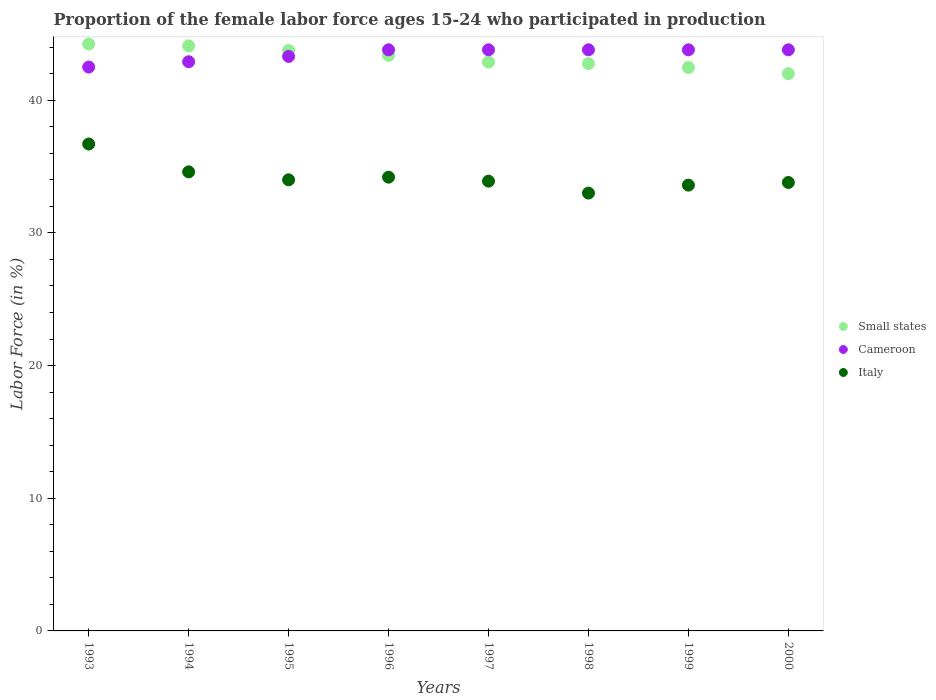How many different coloured dotlines are there?
Your answer should be compact. 3. Is the number of dotlines equal to the number of legend labels?
Offer a terse response. Yes. What is the proportion of the female labor force who participated in production in Cameroon in 1999?
Provide a short and direct response. 43.8. Across all years, what is the maximum proportion of the female labor force who participated in production in Small states?
Your response must be concise. 44.24. Across all years, what is the minimum proportion of the female labor force who participated in production in Small states?
Ensure brevity in your answer.  42. In which year was the proportion of the female labor force who participated in production in Cameroon maximum?
Provide a succinct answer. 1996. What is the total proportion of the female labor force who participated in production in Cameroon in the graph?
Make the answer very short. 347.7. What is the difference between the proportion of the female labor force who participated in production in Cameroon in 1994 and that in 2000?
Provide a succinct answer. -0.9. What is the difference between the proportion of the female labor force who participated in production in Italy in 1998 and the proportion of the female labor force who participated in production in Cameroon in 1997?
Provide a short and direct response. -10.8. What is the average proportion of the female labor force who participated in production in Small states per year?
Your answer should be very brief. 43.19. In the year 1998, what is the difference between the proportion of the female labor force who participated in production in Cameroon and proportion of the female labor force who participated in production in Small states?
Your answer should be compact. 1.04. In how many years, is the proportion of the female labor force who participated in production in Small states greater than 18 %?
Keep it short and to the point. 8. What is the ratio of the proportion of the female labor force who participated in production in Small states in 1994 to that in 1998?
Provide a succinct answer. 1.03. What is the difference between the highest and the lowest proportion of the female labor force who participated in production in Italy?
Provide a succinct answer. 3.7. In how many years, is the proportion of the female labor force who participated in production in Small states greater than the average proportion of the female labor force who participated in production in Small states taken over all years?
Offer a very short reply. 4. Does the proportion of the female labor force who participated in production in Cameroon monotonically increase over the years?
Offer a very short reply. No. How many dotlines are there?
Your answer should be very brief. 3. How many years are there in the graph?
Your response must be concise. 8. What is the difference between two consecutive major ticks on the Y-axis?
Make the answer very short. 10. Are the values on the major ticks of Y-axis written in scientific E-notation?
Provide a short and direct response. No. Does the graph contain any zero values?
Offer a very short reply. No. Does the graph contain grids?
Ensure brevity in your answer.  No. Where does the legend appear in the graph?
Your answer should be very brief. Center right. What is the title of the graph?
Provide a short and direct response. Proportion of the female labor force ages 15-24 who participated in production. What is the label or title of the Y-axis?
Your answer should be compact. Labor Force (in %). What is the Labor Force (in %) in Small states in 1993?
Offer a very short reply. 44.24. What is the Labor Force (in %) of Cameroon in 1993?
Give a very brief answer. 42.5. What is the Labor Force (in %) of Italy in 1993?
Give a very brief answer. 36.7. What is the Labor Force (in %) in Small states in 1994?
Provide a short and direct response. 44.1. What is the Labor Force (in %) of Cameroon in 1994?
Provide a succinct answer. 42.9. What is the Labor Force (in %) of Italy in 1994?
Give a very brief answer. 34.6. What is the Labor Force (in %) of Small states in 1995?
Make the answer very short. 43.75. What is the Labor Force (in %) in Cameroon in 1995?
Provide a succinct answer. 43.3. What is the Labor Force (in %) in Italy in 1995?
Offer a very short reply. 34. What is the Labor Force (in %) of Small states in 1996?
Give a very brief answer. 43.38. What is the Labor Force (in %) in Cameroon in 1996?
Provide a succinct answer. 43.8. What is the Labor Force (in %) of Italy in 1996?
Give a very brief answer. 34.2. What is the Labor Force (in %) in Small states in 1997?
Your answer should be very brief. 42.88. What is the Labor Force (in %) in Cameroon in 1997?
Your response must be concise. 43.8. What is the Labor Force (in %) in Italy in 1997?
Ensure brevity in your answer.  33.9. What is the Labor Force (in %) in Small states in 1998?
Your answer should be very brief. 42.76. What is the Labor Force (in %) of Cameroon in 1998?
Provide a succinct answer. 43.8. What is the Labor Force (in %) in Small states in 1999?
Your response must be concise. 42.46. What is the Labor Force (in %) of Cameroon in 1999?
Provide a short and direct response. 43.8. What is the Labor Force (in %) of Italy in 1999?
Give a very brief answer. 33.6. What is the Labor Force (in %) in Small states in 2000?
Keep it short and to the point. 42. What is the Labor Force (in %) of Cameroon in 2000?
Keep it short and to the point. 43.8. What is the Labor Force (in %) in Italy in 2000?
Make the answer very short. 33.8. Across all years, what is the maximum Labor Force (in %) in Small states?
Your response must be concise. 44.24. Across all years, what is the maximum Labor Force (in %) of Cameroon?
Keep it short and to the point. 43.8. Across all years, what is the maximum Labor Force (in %) of Italy?
Your answer should be compact. 36.7. Across all years, what is the minimum Labor Force (in %) of Small states?
Offer a terse response. 42. Across all years, what is the minimum Labor Force (in %) of Cameroon?
Give a very brief answer. 42.5. Across all years, what is the minimum Labor Force (in %) in Italy?
Your response must be concise. 33. What is the total Labor Force (in %) of Small states in the graph?
Give a very brief answer. 345.56. What is the total Labor Force (in %) of Cameroon in the graph?
Ensure brevity in your answer.  347.7. What is the total Labor Force (in %) in Italy in the graph?
Make the answer very short. 273.8. What is the difference between the Labor Force (in %) of Small states in 1993 and that in 1994?
Provide a succinct answer. 0.14. What is the difference between the Labor Force (in %) in Cameroon in 1993 and that in 1994?
Your response must be concise. -0.4. What is the difference between the Labor Force (in %) in Italy in 1993 and that in 1994?
Your answer should be very brief. 2.1. What is the difference between the Labor Force (in %) in Small states in 1993 and that in 1995?
Make the answer very short. 0.49. What is the difference between the Labor Force (in %) in Cameroon in 1993 and that in 1995?
Provide a short and direct response. -0.8. What is the difference between the Labor Force (in %) of Small states in 1993 and that in 1996?
Keep it short and to the point. 0.85. What is the difference between the Labor Force (in %) of Cameroon in 1993 and that in 1996?
Your answer should be very brief. -1.3. What is the difference between the Labor Force (in %) of Italy in 1993 and that in 1996?
Ensure brevity in your answer.  2.5. What is the difference between the Labor Force (in %) of Small states in 1993 and that in 1997?
Provide a short and direct response. 1.36. What is the difference between the Labor Force (in %) in Cameroon in 1993 and that in 1997?
Your response must be concise. -1.3. What is the difference between the Labor Force (in %) in Small states in 1993 and that in 1998?
Your response must be concise. 1.48. What is the difference between the Labor Force (in %) in Small states in 1993 and that in 1999?
Offer a very short reply. 1.77. What is the difference between the Labor Force (in %) of Cameroon in 1993 and that in 1999?
Your answer should be very brief. -1.3. What is the difference between the Labor Force (in %) of Italy in 1993 and that in 1999?
Offer a terse response. 3.1. What is the difference between the Labor Force (in %) of Small states in 1993 and that in 2000?
Your answer should be compact. 2.23. What is the difference between the Labor Force (in %) in Cameroon in 1993 and that in 2000?
Your answer should be compact. -1.3. What is the difference between the Labor Force (in %) in Italy in 1993 and that in 2000?
Keep it short and to the point. 2.9. What is the difference between the Labor Force (in %) in Small states in 1994 and that in 1995?
Your response must be concise. 0.35. What is the difference between the Labor Force (in %) in Italy in 1994 and that in 1995?
Ensure brevity in your answer.  0.6. What is the difference between the Labor Force (in %) of Small states in 1994 and that in 1996?
Offer a terse response. 0.72. What is the difference between the Labor Force (in %) in Small states in 1994 and that in 1997?
Your answer should be very brief. 1.22. What is the difference between the Labor Force (in %) in Cameroon in 1994 and that in 1997?
Ensure brevity in your answer.  -0.9. What is the difference between the Labor Force (in %) of Italy in 1994 and that in 1997?
Offer a terse response. 0.7. What is the difference between the Labor Force (in %) in Small states in 1994 and that in 1998?
Ensure brevity in your answer.  1.34. What is the difference between the Labor Force (in %) of Cameroon in 1994 and that in 1998?
Provide a short and direct response. -0.9. What is the difference between the Labor Force (in %) of Small states in 1994 and that in 1999?
Provide a succinct answer. 1.63. What is the difference between the Labor Force (in %) of Italy in 1994 and that in 1999?
Give a very brief answer. 1. What is the difference between the Labor Force (in %) in Small states in 1994 and that in 2000?
Keep it short and to the point. 2.09. What is the difference between the Labor Force (in %) of Cameroon in 1994 and that in 2000?
Provide a succinct answer. -0.9. What is the difference between the Labor Force (in %) in Italy in 1994 and that in 2000?
Your answer should be compact. 0.8. What is the difference between the Labor Force (in %) in Small states in 1995 and that in 1996?
Keep it short and to the point. 0.36. What is the difference between the Labor Force (in %) in Cameroon in 1995 and that in 1996?
Your answer should be compact. -0.5. What is the difference between the Labor Force (in %) in Small states in 1995 and that in 1997?
Provide a succinct answer. 0.87. What is the difference between the Labor Force (in %) of Cameroon in 1995 and that in 1997?
Ensure brevity in your answer.  -0.5. What is the difference between the Labor Force (in %) of Italy in 1995 and that in 1997?
Provide a short and direct response. 0.1. What is the difference between the Labor Force (in %) of Small states in 1995 and that in 1998?
Give a very brief answer. 0.99. What is the difference between the Labor Force (in %) of Small states in 1995 and that in 1999?
Your response must be concise. 1.28. What is the difference between the Labor Force (in %) in Italy in 1995 and that in 1999?
Offer a very short reply. 0.4. What is the difference between the Labor Force (in %) in Small states in 1995 and that in 2000?
Provide a succinct answer. 1.74. What is the difference between the Labor Force (in %) in Italy in 1995 and that in 2000?
Offer a terse response. 0.2. What is the difference between the Labor Force (in %) of Small states in 1996 and that in 1997?
Keep it short and to the point. 0.5. What is the difference between the Labor Force (in %) in Small states in 1996 and that in 1998?
Your response must be concise. 0.62. What is the difference between the Labor Force (in %) of Cameroon in 1996 and that in 1998?
Give a very brief answer. 0. What is the difference between the Labor Force (in %) in Italy in 1996 and that in 1998?
Keep it short and to the point. 1.2. What is the difference between the Labor Force (in %) in Small states in 1996 and that in 1999?
Make the answer very short. 0.92. What is the difference between the Labor Force (in %) in Small states in 1996 and that in 2000?
Give a very brief answer. 1.38. What is the difference between the Labor Force (in %) of Cameroon in 1996 and that in 2000?
Provide a short and direct response. 0. What is the difference between the Labor Force (in %) in Small states in 1997 and that in 1998?
Offer a very short reply. 0.12. What is the difference between the Labor Force (in %) of Cameroon in 1997 and that in 1998?
Offer a very short reply. 0. What is the difference between the Labor Force (in %) of Italy in 1997 and that in 1998?
Your response must be concise. 0.9. What is the difference between the Labor Force (in %) in Small states in 1997 and that in 1999?
Provide a succinct answer. 0.41. What is the difference between the Labor Force (in %) of Italy in 1997 and that in 1999?
Your answer should be very brief. 0.3. What is the difference between the Labor Force (in %) of Small states in 1997 and that in 2000?
Make the answer very short. 0.88. What is the difference between the Labor Force (in %) of Italy in 1997 and that in 2000?
Offer a terse response. 0.1. What is the difference between the Labor Force (in %) in Small states in 1998 and that in 1999?
Offer a terse response. 0.29. What is the difference between the Labor Force (in %) of Cameroon in 1998 and that in 1999?
Ensure brevity in your answer.  0. What is the difference between the Labor Force (in %) in Italy in 1998 and that in 1999?
Offer a very short reply. -0.6. What is the difference between the Labor Force (in %) in Small states in 1998 and that in 2000?
Your response must be concise. 0.75. What is the difference between the Labor Force (in %) in Cameroon in 1998 and that in 2000?
Make the answer very short. 0. What is the difference between the Labor Force (in %) of Small states in 1999 and that in 2000?
Offer a terse response. 0.46. What is the difference between the Labor Force (in %) in Cameroon in 1999 and that in 2000?
Your answer should be very brief. 0. What is the difference between the Labor Force (in %) in Italy in 1999 and that in 2000?
Keep it short and to the point. -0.2. What is the difference between the Labor Force (in %) of Small states in 1993 and the Labor Force (in %) of Cameroon in 1994?
Keep it short and to the point. 1.33. What is the difference between the Labor Force (in %) in Small states in 1993 and the Labor Force (in %) in Italy in 1994?
Your answer should be very brief. 9.63. What is the difference between the Labor Force (in %) in Small states in 1993 and the Labor Force (in %) in Cameroon in 1995?
Your response must be concise. 0.94. What is the difference between the Labor Force (in %) of Small states in 1993 and the Labor Force (in %) of Italy in 1995?
Your answer should be very brief. 10.23. What is the difference between the Labor Force (in %) in Small states in 1993 and the Labor Force (in %) in Cameroon in 1996?
Provide a short and direct response. 0.43. What is the difference between the Labor Force (in %) of Small states in 1993 and the Labor Force (in %) of Italy in 1996?
Your answer should be very brief. 10.04. What is the difference between the Labor Force (in %) in Cameroon in 1993 and the Labor Force (in %) in Italy in 1996?
Your answer should be compact. 8.3. What is the difference between the Labor Force (in %) in Small states in 1993 and the Labor Force (in %) in Cameroon in 1997?
Ensure brevity in your answer.  0.43. What is the difference between the Labor Force (in %) of Small states in 1993 and the Labor Force (in %) of Italy in 1997?
Provide a short and direct response. 10.34. What is the difference between the Labor Force (in %) in Cameroon in 1993 and the Labor Force (in %) in Italy in 1997?
Ensure brevity in your answer.  8.6. What is the difference between the Labor Force (in %) in Small states in 1993 and the Labor Force (in %) in Cameroon in 1998?
Keep it short and to the point. 0.43. What is the difference between the Labor Force (in %) in Small states in 1993 and the Labor Force (in %) in Italy in 1998?
Ensure brevity in your answer.  11.23. What is the difference between the Labor Force (in %) in Small states in 1993 and the Labor Force (in %) in Cameroon in 1999?
Keep it short and to the point. 0.43. What is the difference between the Labor Force (in %) of Small states in 1993 and the Labor Force (in %) of Italy in 1999?
Ensure brevity in your answer.  10.63. What is the difference between the Labor Force (in %) in Cameroon in 1993 and the Labor Force (in %) in Italy in 1999?
Offer a terse response. 8.9. What is the difference between the Labor Force (in %) of Small states in 1993 and the Labor Force (in %) of Cameroon in 2000?
Offer a very short reply. 0.43. What is the difference between the Labor Force (in %) of Small states in 1993 and the Labor Force (in %) of Italy in 2000?
Provide a succinct answer. 10.44. What is the difference between the Labor Force (in %) in Cameroon in 1993 and the Labor Force (in %) in Italy in 2000?
Ensure brevity in your answer.  8.7. What is the difference between the Labor Force (in %) in Small states in 1994 and the Labor Force (in %) in Cameroon in 1995?
Make the answer very short. 0.8. What is the difference between the Labor Force (in %) of Small states in 1994 and the Labor Force (in %) of Italy in 1995?
Keep it short and to the point. 10.1. What is the difference between the Labor Force (in %) in Cameroon in 1994 and the Labor Force (in %) in Italy in 1995?
Offer a terse response. 8.9. What is the difference between the Labor Force (in %) of Small states in 1994 and the Labor Force (in %) of Cameroon in 1996?
Your answer should be very brief. 0.3. What is the difference between the Labor Force (in %) in Small states in 1994 and the Labor Force (in %) in Italy in 1996?
Ensure brevity in your answer.  9.9. What is the difference between the Labor Force (in %) of Cameroon in 1994 and the Labor Force (in %) of Italy in 1996?
Offer a very short reply. 8.7. What is the difference between the Labor Force (in %) in Small states in 1994 and the Labor Force (in %) in Cameroon in 1997?
Offer a very short reply. 0.3. What is the difference between the Labor Force (in %) of Small states in 1994 and the Labor Force (in %) of Italy in 1997?
Provide a succinct answer. 10.2. What is the difference between the Labor Force (in %) in Cameroon in 1994 and the Labor Force (in %) in Italy in 1997?
Your response must be concise. 9. What is the difference between the Labor Force (in %) of Small states in 1994 and the Labor Force (in %) of Cameroon in 1998?
Offer a very short reply. 0.3. What is the difference between the Labor Force (in %) of Small states in 1994 and the Labor Force (in %) of Italy in 1998?
Offer a very short reply. 11.1. What is the difference between the Labor Force (in %) in Small states in 1994 and the Labor Force (in %) in Cameroon in 1999?
Offer a terse response. 0.3. What is the difference between the Labor Force (in %) of Small states in 1994 and the Labor Force (in %) of Italy in 1999?
Ensure brevity in your answer.  10.5. What is the difference between the Labor Force (in %) of Cameroon in 1994 and the Labor Force (in %) of Italy in 1999?
Your answer should be compact. 9.3. What is the difference between the Labor Force (in %) of Small states in 1994 and the Labor Force (in %) of Cameroon in 2000?
Your answer should be very brief. 0.3. What is the difference between the Labor Force (in %) of Small states in 1994 and the Labor Force (in %) of Italy in 2000?
Offer a terse response. 10.3. What is the difference between the Labor Force (in %) of Cameroon in 1994 and the Labor Force (in %) of Italy in 2000?
Make the answer very short. 9.1. What is the difference between the Labor Force (in %) of Small states in 1995 and the Labor Force (in %) of Cameroon in 1996?
Offer a terse response. -0.05. What is the difference between the Labor Force (in %) of Small states in 1995 and the Labor Force (in %) of Italy in 1996?
Offer a very short reply. 9.55. What is the difference between the Labor Force (in %) of Cameroon in 1995 and the Labor Force (in %) of Italy in 1996?
Give a very brief answer. 9.1. What is the difference between the Labor Force (in %) in Small states in 1995 and the Labor Force (in %) in Cameroon in 1997?
Offer a very short reply. -0.05. What is the difference between the Labor Force (in %) in Small states in 1995 and the Labor Force (in %) in Italy in 1997?
Your response must be concise. 9.85. What is the difference between the Labor Force (in %) of Small states in 1995 and the Labor Force (in %) of Cameroon in 1998?
Make the answer very short. -0.05. What is the difference between the Labor Force (in %) of Small states in 1995 and the Labor Force (in %) of Italy in 1998?
Provide a succinct answer. 10.75. What is the difference between the Labor Force (in %) in Small states in 1995 and the Labor Force (in %) in Cameroon in 1999?
Your answer should be very brief. -0.05. What is the difference between the Labor Force (in %) of Small states in 1995 and the Labor Force (in %) of Italy in 1999?
Keep it short and to the point. 10.15. What is the difference between the Labor Force (in %) of Cameroon in 1995 and the Labor Force (in %) of Italy in 1999?
Offer a very short reply. 9.7. What is the difference between the Labor Force (in %) of Small states in 1995 and the Labor Force (in %) of Cameroon in 2000?
Offer a terse response. -0.05. What is the difference between the Labor Force (in %) of Small states in 1995 and the Labor Force (in %) of Italy in 2000?
Offer a terse response. 9.95. What is the difference between the Labor Force (in %) of Small states in 1996 and the Labor Force (in %) of Cameroon in 1997?
Make the answer very short. -0.42. What is the difference between the Labor Force (in %) in Small states in 1996 and the Labor Force (in %) in Italy in 1997?
Your response must be concise. 9.48. What is the difference between the Labor Force (in %) in Cameroon in 1996 and the Labor Force (in %) in Italy in 1997?
Offer a terse response. 9.9. What is the difference between the Labor Force (in %) in Small states in 1996 and the Labor Force (in %) in Cameroon in 1998?
Your response must be concise. -0.42. What is the difference between the Labor Force (in %) of Small states in 1996 and the Labor Force (in %) of Italy in 1998?
Keep it short and to the point. 10.38. What is the difference between the Labor Force (in %) of Cameroon in 1996 and the Labor Force (in %) of Italy in 1998?
Provide a short and direct response. 10.8. What is the difference between the Labor Force (in %) in Small states in 1996 and the Labor Force (in %) in Cameroon in 1999?
Keep it short and to the point. -0.42. What is the difference between the Labor Force (in %) of Small states in 1996 and the Labor Force (in %) of Italy in 1999?
Offer a terse response. 9.78. What is the difference between the Labor Force (in %) of Small states in 1996 and the Labor Force (in %) of Cameroon in 2000?
Provide a short and direct response. -0.42. What is the difference between the Labor Force (in %) of Small states in 1996 and the Labor Force (in %) of Italy in 2000?
Make the answer very short. 9.58. What is the difference between the Labor Force (in %) in Small states in 1997 and the Labor Force (in %) in Cameroon in 1998?
Keep it short and to the point. -0.92. What is the difference between the Labor Force (in %) of Small states in 1997 and the Labor Force (in %) of Italy in 1998?
Your answer should be very brief. 9.88. What is the difference between the Labor Force (in %) of Small states in 1997 and the Labor Force (in %) of Cameroon in 1999?
Make the answer very short. -0.92. What is the difference between the Labor Force (in %) of Small states in 1997 and the Labor Force (in %) of Italy in 1999?
Keep it short and to the point. 9.28. What is the difference between the Labor Force (in %) in Cameroon in 1997 and the Labor Force (in %) in Italy in 1999?
Make the answer very short. 10.2. What is the difference between the Labor Force (in %) of Small states in 1997 and the Labor Force (in %) of Cameroon in 2000?
Offer a terse response. -0.92. What is the difference between the Labor Force (in %) of Small states in 1997 and the Labor Force (in %) of Italy in 2000?
Give a very brief answer. 9.08. What is the difference between the Labor Force (in %) of Small states in 1998 and the Labor Force (in %) of Cameroon in 1999?
Your answer should be compact. -1.04. What is the difference between the Labor Force (in %) of Small states in 1998 and the Labor Force (in %) of Italy in 1999?
Keep it short and to the point. 9.16. What is the difference between the Labor Force (in %) of Cameroon in 1998 and the Labor Force (in %) of Italy in 1999?
Your answer should be very brief. 10.2. What is the difference between the Labor Force (in %) of Small states in 1998 and the Labor Force (in %) of Cameroon in 2000?
Your answer should be very brief. -1.04. What is the difference between the Labor Force (in %) in Small states in 1998 and the Labor Force (in %) in Italy in 2000?
Keep it short and to the point. 8.96. What is the difference between the Labor Force (in %) in Cameroon in 1998 and the Labor Force (in %) in Italy in 2000?
Your response must be concise. 10. What is the difference between the Labor Force (in %) in Small states in 1999 and the Labor Force (in %) in Cameroon in 2000?
Your answer should be compact. -1.34. What is the difference between the Labor Force (in %) of Small states in 1999 and the Labor Force (in %) of Italy in 2000?
Make the answer very short. 8.66. What is the difference between the Labor Force (in %) in Cameroon in 1999 and the Labor Force (in %) in Italy in 2000?
Provide a succinct answer. 10. What is the average Labor Force (in %) in Small states per year?
Provide a short and direct response. 43.19. What is the average Labor Force (in %) in Cameroon per year?
Provide a short and direct response. 43.46. What is the average Labor Force (in %) of Italy per year?
Give a very brief answer. 34.23. In the year 1993, what is the difference between the Labor Force (in %) in Small states and Labor Force (in %) in Cameroon?
Keep it short and to the point. 1.74. In the year 1993, what is the difference between the Labor Force (in %) in Small states and Labor Force (in %) in Italy?
Make the answer very short. 7.54. In the year 1994, what is the difference between the Labor Force (in %) of Small states and Labor Force (in %) of Cameroon?
Your answer should be compact. 1.2. In the year 1994, what is the difference between the Labor Force (in %) in Small states and Labor Force (in %) in Italy?
Your answer should be compact. 9.5. In the year 1994, what is the difference between the Labor Force (in %) of Cameroon and Labor Force (in %) of Italy?
Your answer should be very brief. 8.3. In the year 1995, what is the difference between the Labor Force (in %) in Small states and Labor Force (in %) in Cameroon?
Give a very brief answer. 0.45. In the year 1995, what is the difference between the Labor Force (in %) of Small states and Labor Force (in %) of Italy?
Provide a short and direct response. 9.75. In the year 1996, what is the difference between the Labor Force (in %) in Small states and Labor Force (in %) in Cameroon?
Give a very brief answer. -0.42. In the year 1996, what is the difference between the Labor Force (in %) in Small states and Labor Force (in %) in Italy?
Your response must be concise. 9.18. In the year 1996, what is the difference between the Labor Force (in %) in Cameroon and Labor Force (in %) in Italy?
Make the answer very short. 9.6. In the year 1997, what is the difference between the Labor Force (in %) of Small states and Labor Force (in %) of Cameroon?
Provide a short and direct response. -0.92. In the year 1997, what is the difference between the Labor Force (in %) in Small states and Labor Force (in %) in Italy?
Keep it short and to the point. 8.98. In the year 1998, what is the difference between the Labor Force (in %) of Small states and Labor Force (in %) of Cameroon?
Keep it short and to the point. -1.04. In the year 1998, what is the difference between the Labor Force (in %) of Small states and Labor Force (in %) of Italy?
Offer a terse response. 9.76. In the year 1999, what is the difference between the Labor Force (in %) of Small states and Labor Force (in %) of Cameroon?
Provide a succinct answer. -1.34. In the year 1999, what is the difference between the Labor Force (in %) in Small states and Labor Force (in %) in Italy?
Keep it short and to the point. 8.86. In the year 2000, what is the difference between the Labor Force (in %) of Small states and Labor Force (in %) of Cameroon?
Offer a very short reply. -1.8. In the year 2000, what is the difference between the Labor Force (in %) of Small states and Labor Force (in %) of Italy?
Provide a short and direct response. 8.2. What is the ratio of the Labor Force (in %) of Italy in 1993 to that in 1994?
Give a very brief answer. 1.06. What is the ratio of the Labor Force (in %) in Small states in 1993 to that in 1995?
Your answer should be very brief. 1.01. What is the ratio of the Labor Force (in %) of Cameroon in 1993 to that in 1995?
Your response must be concise. 0.98. What is the ratio of the Labor Force (in %) in Italy in 1993 to that in 1995?
Your answer should be compact. 1.08. What is the ratio of the Labor Force (in %) of Small states in 1993 to that in 1996?
Provide a succinct answer. 1.02. What is the ratio of the Labor Force (in %) in Cameroon in 1993 to that in 1996?
Your response must be concise. 0.97. What is the ratio of the Labor Force (in %) in Italy in 1993 to that in 1996?
Make the answer very short. 1.07. What is the ratio of the Labor Force (in %) of Small states in 1993 to that in 1997?
Give a very brief answer. 1.03. What is the ratio of the Labor Force (in %) in Cameroon in 1993 to that in 1997?
Your response must be concise. 0.97. What is the ratio of the Labor Force (in %) of Italy in 1993 to that in 1997?
Ensure brevity in your answer.  1.08. What is the ratio of the Labor Force (in %) of Small states in 1993 to that in 1998?
Give a very brief answer. 1.03. What is the ratio of the Labor Force (in %) in Cameroon in 1993 to that in 1998?
Ensure brevity in your answer.  0.97. What is the ratio of the Labor Force (in %) in Italy in 1993 to that in 1998?
Offer a terse response. 1.11. What is the ratio of the Labor Force (in %) of Small states in 1993 to that in 1999?
Keep it short and to the point. 1.04. What is the ratio of the Labor Force (in %) in Cameroon in 1993 to that in 1999?
Ensure brevity in your answer.  0.97. What is the ratio of the Labor Force (in %) in Italy in 1993 to that in 1999?
Keep it short and to the point. 1.09. What is the ratio of the Labor Force (in %) in Small states in 1993 to that in 2000?
Your response must be concise. 1.05. What is the ratio of the Labor Force (in %) in Cameroon in 1993 to that in 2000?
Keep it short and to the point. 0.97. What is the ratio of the Labor Force (in %) in Italy in 1993 to that in 2000?
Provide a short and direct response. 1.09. What is the ratio of the Labor Force (in %) of Small states in 1994 to that in 1995?
Provide a succinct answer. 1.01. What is the ratio of the Labor Force (in %) in Italy in 1994 to that in 1995?
Your answer should be very brief. 1.02. What is the ratio of the Labor Force (in %) in Small states in 1994 to that in 1996?
Give a very brief answer. 1.02. What is the ratio of the Labor Force (in %) of Cameroon in 1994 to that in 1996?
Make the answer very short. 0.98. What is the ratio of the Labor Force (in %) of Italy in 1994 to that in 1996?
Your answer should be very brief. 1.01. What is the ratio of the Labor Force (in %) in Small states in 1994 to that in 1997?
Provide a short and direct response. 1.03. What is the ratio of the Labor Force (in %) in Cameroon in 1994 to that in 1997?
Your response must be concise. 0.98. What is the ratio of the Labor Force (in %) in Italy in 1994 to that in 1997?
Offer a terse response. 1.02. What is the ratio of the Labor Force (in %) in Small states in 1994 to that in 1998?
Offer a very short reply. 1.03. What is the ratio of the Labor Force (in %) of Cameroon in 1994 to that in 1998?
Provide a succinct answer. 0.98. What is the ratio of the Labor Force (in %) of Italy in 1994 to that in 1998?
Offer a terse response. 1.05. What is the ratio of the Labor Force (in %) of Small states in 1994 to that in 1999?
Provide a short and direct response. 1.04. What is the ratio of the Labor Force (in %) of Cameroon in 1994 to that in 1999?
Make the answer very short. 0.98. What is the ratio of the Labor Force (in %) of Italy in 1994 to that in 1999?
Provide a succinct answer. 1.03. What is the ratio of the Labor Force (in %) of Small states in 1994 to that in 2000?
Keep it short and to the point. 1.05. What is the ratio of the Labor Force (in %) in Cameroon in 1994 to that in 2000?
Offer a terse response. 0.98. What is the ratio of the Labor Force (in %) of Italy in 1994 to that in 2000?
Your response must be concise. 1.02. What is the ratio of the Labor Force (in %) of Small states in 1995 to that in 1996?
Your response must be concise. 1.01. What is the ratio of the Labor Force (in %) in Italy in 1995 to that in 1996?
Make the answer very short. 0.99. What is the ratio of the Labor Force (in %) in Small states in 1995 to that in 1997?
Make the answer very short. 1.02. What is the ratio of the Labor Force (in %) in Italy in 1995 to that in 1997?
Provide a succinct answer. 1. What is the ratio of the Labor Force (in %) of Small states in 1995 to that in 1998?
Offer a very short reply. 1.02. What is the ratio of the Labor Force (in %) in Italy in 1995 to that in 1998?
Give a very brief answer. 1.03. What is the ratio of the Labor Force (in %) in Small states in 1995 to that in 1999?
Your answer should be very brief. 1.03. What is the ratio of the Labor Force (in %) in Cameroon in 1995 to that in 1999?
Make the answer very short. 0.99. What is the ratio of the Labor Force (in %) in Italy in 1995 to that in 1999?
Keep it short and to the point. 1.01. What is the ratio of the Labor Force (in %) in Small states in 1995 to that in 2000?
Your response must be concise. 1.04. What is the ratio of the Labor Force (in %) in Italy in 1995 to that in 2000?
Keep it short and to the point. 1.01. What is the ratio of the Labor Force (in %) in Small states in 1996 to that in 1997?
Give a very brief answer. 1.01. What is the ratio of the Labor Force (in %) in Italy in 1996 to that in 1997?
Make the answer very short. 1.01. What is the ratio of the Labor Force (in %) of Small states in 1996 to that in 1998?
Your answer should be very brief. 1.01. What is the ratio of the Labor Force (in %) of Italy in 1996 to that in 1998?
Make the answer very short. 1.04. What is the ratio of the Labor Force (in %) of Small states in 1996 to that in 1999?
Your response must be concise. 1.02. What is the ratio of the Labor Force (in %) of Cameroon in 1996 to that in 1999?
Your answer should be compact. 1. What is the ratio of the Labor Force (in %) of Italy in 1996 to that in 1999?
Provide a succinct answer. 1.02. What is the ratio of the Labor Force (in %) of Small states in 1996 to that in 2000?
Offer a very short reply. 1.03. What is the ratio of the Labor Force (in %) in Italy in 1996 to that in 2000?
Offer a terse response. 1.01. What is the ratio of the Labor Force (in %) in Cameroon in 1997 to that in 1998?
Give a very brief answer. 1. What is the ratio of the Labor Force (in %) of Italy in 1997 to that in 1998?
Give a very brief answer. 1.03. What is the ratio of the Labor Force (in %) in Small states in 1997 to that in 1999?
Your answer should be compact. 1.01. What is the ratio of the Labor Force (in %) in Cameroon in 1997 to that in 1999?
Your response must be concise. 1. What is the ratio of the Labor Force (in %) of Italy in 1997 to that in 1999?
Give a very brief answer. 1.01. What is the ratio of the Labor Force (in %) of Small states in 1997 to that in 2000?
Provide a short and direct response. 1.02. What is the ratio of the Labor Force (in %) of Cameroon in 1998 to that in 1999?
Your answer should be compact. 1. What is the ratio of the Labor Force (in %) in Italy in 1998 to that in 1999?
Give a very brief answer. 0.98. What is the ratio of the Labor Force (in %) of Small states in 1998 to that in 2000?
Ensure brevity in your answer.  1.02. What is the ratio of the Labor Force (in %) in Cameroon in 1998 to that in 2000?
Offer a very short reply. 1. What is the ratio of the Labor Force (in %) in Italy in 1998 to that in 2000?
Offer a terse response. 0.98. What is the ratio of the Labor Force (in %) of Small states in 1999 to that in 2000?
Your response must be concise. 1.01. What is the ratio of the Labor Force (in %) in Italy in 1999 to that in 2000?
Offer a terse response. 0.99. What is the difference between the highest and the second highest Labor Force (in %) of Small states?
Provide a short and direct response. 0.14. What is the difference between the highest and the second highest Labor Force (in %) in Italy?
Your answer should be compact. 2.1. What is the difference between the highest and the lowest Labor Force (in %) in Small states?
Your response must be concise. 2.23. 